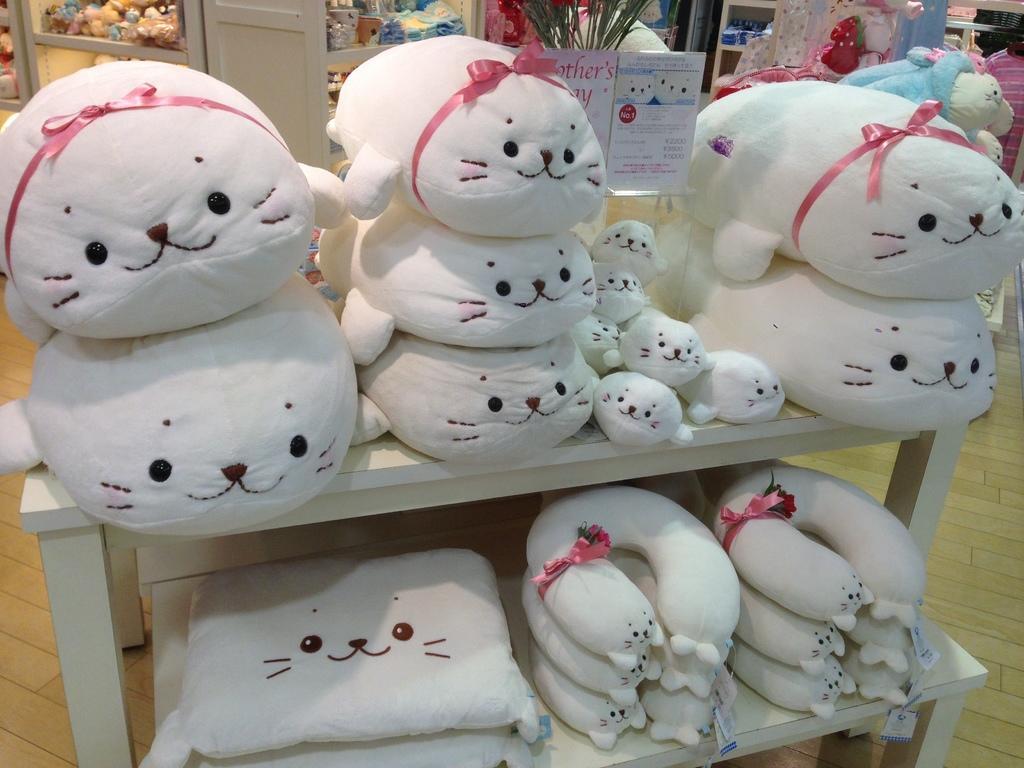In one or two sentences, can you explain what this image depicts? In this image we can see toys and neck pillows placed on the shelves. In the background we can see doors, toys, greeting card and plant. 